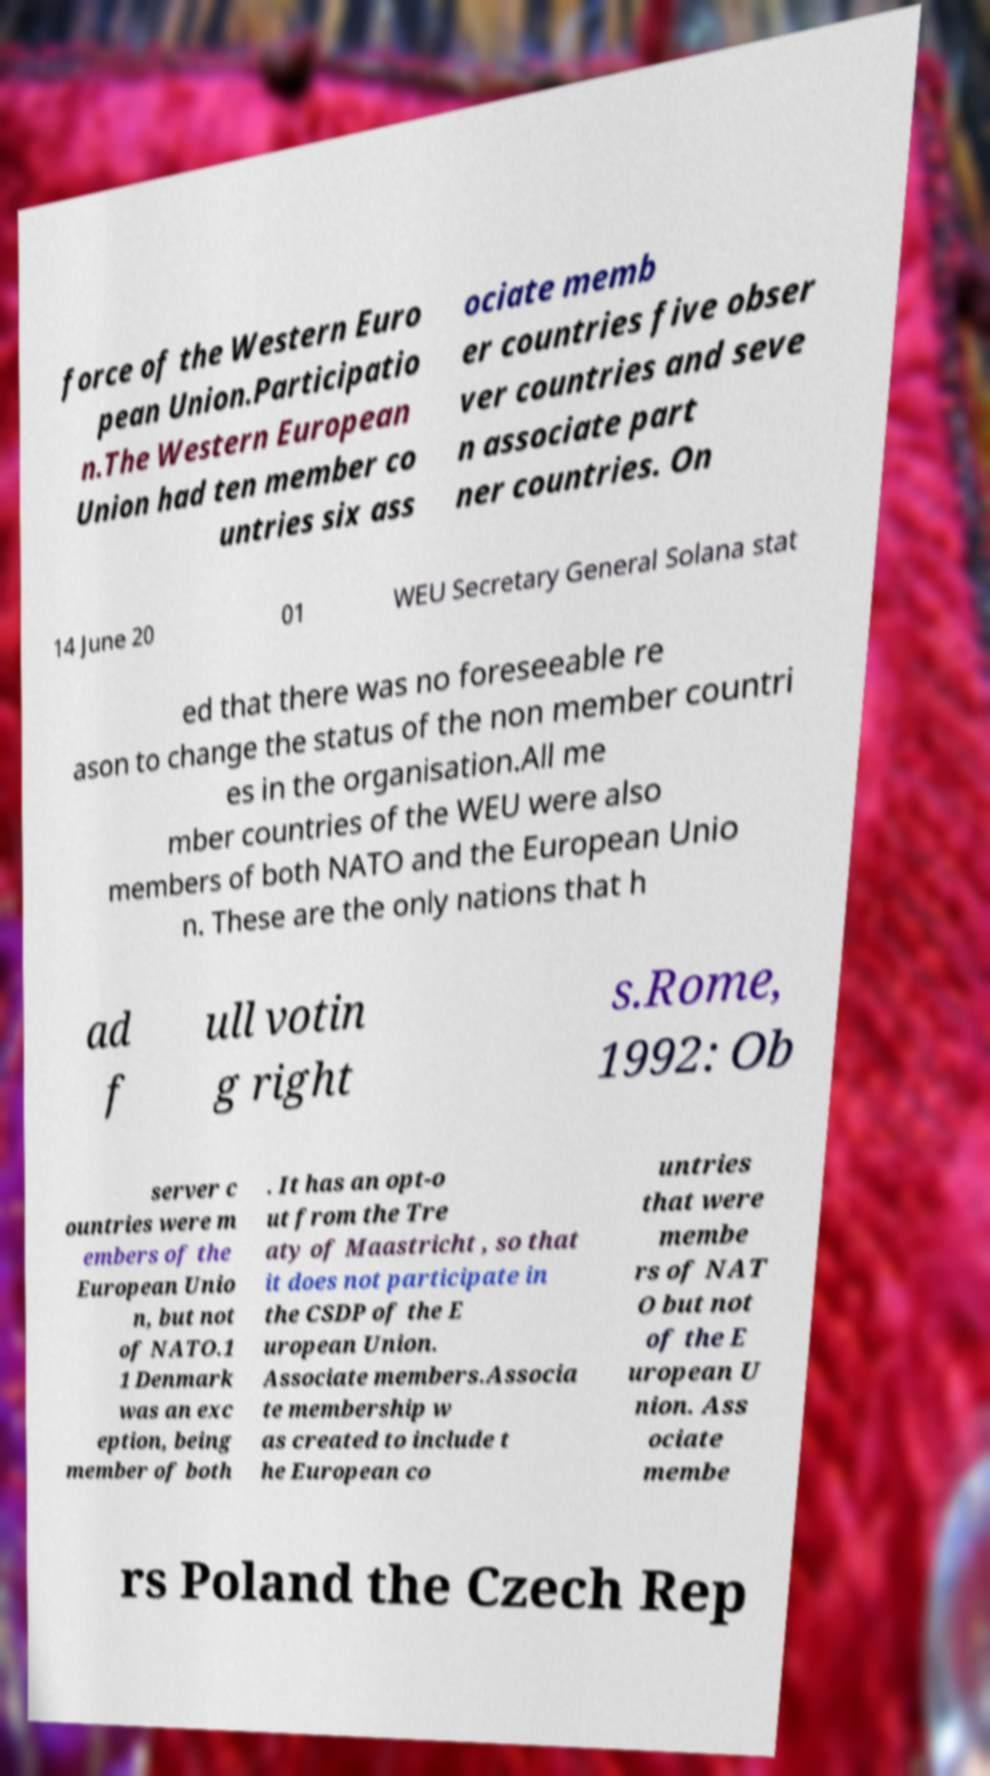For documentation purposes, I need the text within this image transcribed. Could you provide that? force of the Western Euro pean Union.Participatio n.The Western European Union had ten member co untries six ass ociate memb er countries five obser ver countries and seve n associate part ner countries. On 14 June 20 01 WEU Secretary General Solana stat ed that there was no foreseeable re ason to change the status of the non member countri es in the organisation.All me mber countries of the WEU were also members of both NATO and the European Unio n. These are the only nations that h ad f ull votin g right s.Rome, 1992: Ob server c ountries were m embers of the European Unio n, but not of NATO.1 1 Denmark was an exc eption, being member of both . It has an opt-o ut from the Tre aty of Maastricht , so that it does not participate in the CSDP of the E uropean Union. Associate members.Associa te membership w as created to include t he European co untries that were membe rs of NAT O but not of the E uropean U nion. Ass ociate membe rs Poland the Czech Rep 